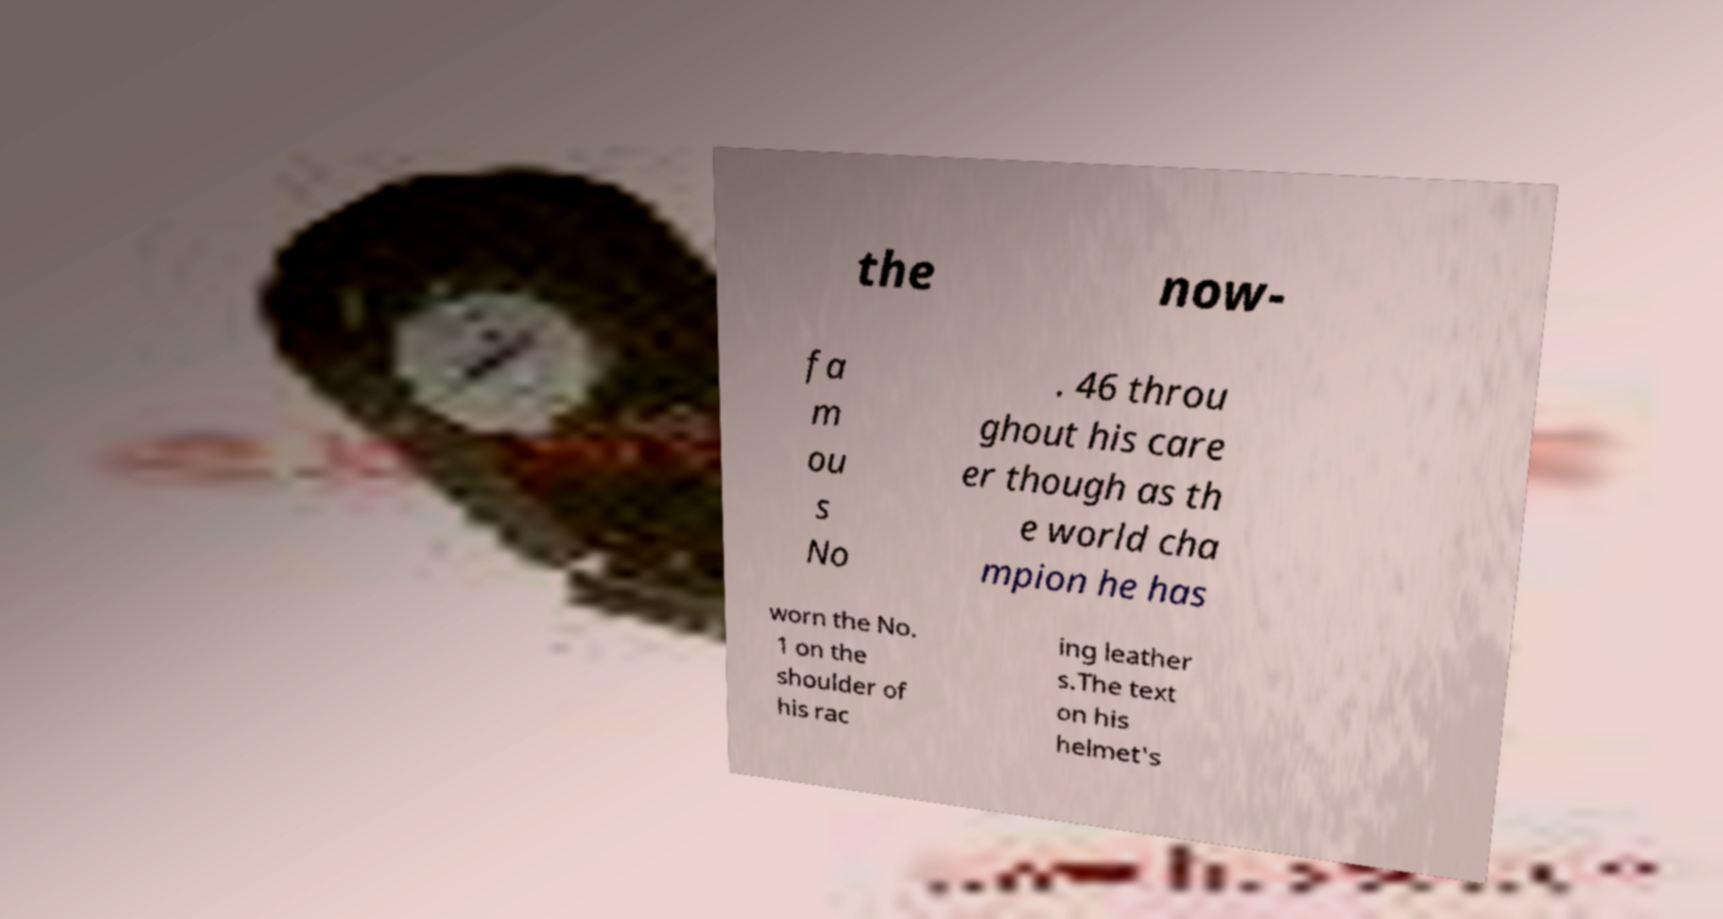Can you accurately transcribe the text from the provided image for me? the now- fa m ou s No . 46 throu ghout his care er though as th e world cha mpion he has worn the No. 1 on the shoulder of his rac ing leather s.The text on his helmet's 